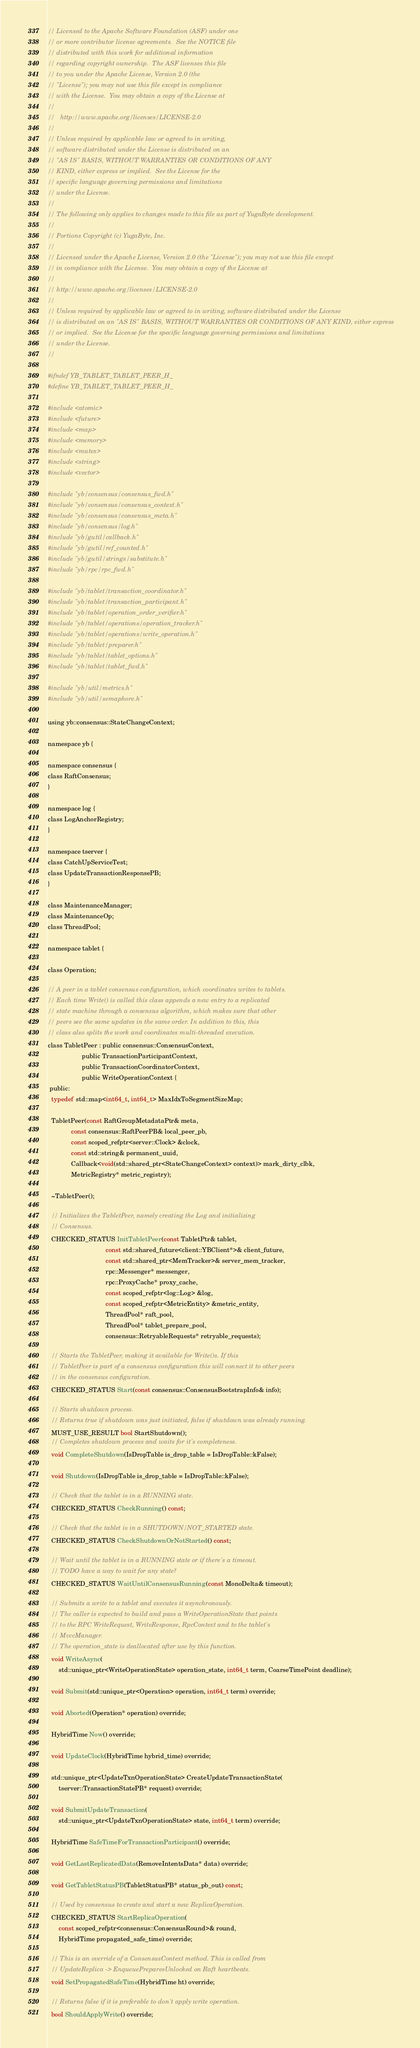<code> <loc_0><loc_0><loc_500><loc_500><_C_>// Licensed to the Apache Software Foundation (ASF) under one
// or more contributor license agreements.  See the NOTICE file
// distributed with this work for additional information
// regarding copyright ownership.  The ASF licenses this file
// to you under the Apache License, Version 2.0 (the
// "License"); you may not use this file except in compliance
// with the License.  You may obtain a copy of the License at
//
//   http://www.apache.org/licenses/LICENSE-2.0
//
// Unless required by applicable law or agreed to in writing,
// software distributed under the License is distributed on an
// "AS IS" BASIS, WITHOUT WARRANTIES OR CONDITIONS OF ANY
// KIND, either express or implied.  See the License for the
// specific language governing permissions and limitations
// under the License.
//
// The following only applies to changes made to this file as part of YugaByte development.
//
// Portions Copyright (c) YugaByte, Inc.
//
// Licensed under the Apache License, Version 2.0 (the "License"); you may not use this file except
// in compliance with the License.  You may obtain a copy of the License at
//
// http://www.apache.org/licenses/LICENSE-2.0
//
// Unless required by applicable law or agreed to in writing, software distributed under the License
// is distributed on an "AS IS" BASIS, WITHOUT WARRANTIES OR CONDITIONS OF ANY KIND, either express
// or implied.  See the License for the specific language governing permissions and limitations
// under the License.
//

#ifndef YB_TABLET_TABLET_PEER_H_
#define YB_TABLET_TABLET_PEER_H_

#include <atomic>
#include <future>
#include <map>
#include <memory>
#include <mutex>
#include <string>
#include <vector>

#include "yb/consensus/consensus_fwd.h"
#include "yb/consensus/consensus_context.h"
#include "yb/consensus/consensus_meta.h"
#include "yb/consensus/log.h"
#include "yb/gutil/callback.h"
#include "yb/gutil/ref_counted.h"
#include "yb/gutil/strings/substitute.h"
#include "yb/rpc/rpc_fwd.h"

#include "yb/tablet/transaction_coordinator.h"
#include "yb/tablet/transaction_participant.h"
#include "yb/tablet/operation_order_verifier.h"
#include "yb/tablet/operations/operation_tracker.h"
#include "yb/tablet/operations/write_operation.h"
#include "yb/tablet/preparer.h"
#include "yb/tablet/tablet_options.h"
#include "yb/tablet/tablet_fwd.h"

#include "yb/util/metrics.h"
#include "yb/util/semaphore.h"

using yb::consensus::StateChangeContext;

namespace yb {

namespace consensus {
class RaftConsensus;
}

namespace log {
class LogAnchorRegistry;
}

namespace tserver {
class CatchUpServiceTest;
class UpdateTransactionResponsePB;
}

class MaintenanceManager;
class MaintenanceOp;
class ThreadPool;

namespace tablet {

class Operation;

// A peer in a tablet consensus configuration, which coordinates writes to tablets.
// Each time Write() is called this class appends a new entry to a replicated
// state machine through a consensus algorithm, which makes sure that other
// peers see the same updates in the same order. In addition to this, this
// class also splits the work and coordinates multi-threaded execution.
class TabletPeer : public consensus::ConsensusContext,
                   public TransactionParticipantContext,
                   public TransactionCoordinatorContext,
                   public WriteOperationContext {
 public:
  typedef std::map<int64_t, int64_t> MaxIdxToSegmentSizeMap;

  TabletPeer(const RaftGroupMetadataPtr& meta,
             const consensus::RaftPeerPB& local_peer_pb,
             const scoped_refptr<server::Clock> &clock,
             const std::string& permanent_uuid,
             Callback<void(std::shared_ptr<StateChangeContext> context)> mark_dirty_clbk,
             MetricRegistry* metric_registry);

  ~TabletPeer();

  // Initializes the TabletPeer, namely creating the Log and initializing
  // Consensus.
  CHECKED_STATUS InitTabletPeer(const TabletPtr& tablet,
                                const std::shared_future<client::YBClient*>& client_future,
                                const std::shared_ptr<MemTracker>& server_mem_tracker,
                                rpc::Messenger* messenger,
                                rpc::ProxyCache* proxy_cache,
                                const scoped_refptr<log::Log> &log,
                                const scoped_refptr<MetricEntity> &metric_entity,
                                ThreadPool* raft_pool,
                                ThreadPool* tablet_prepare_pool,
                                consensus::RetryableRequests* retryable_requests);

  // Starts the TabletPeer, making it available for Write()s. If this
  // TabletPeer is part of a consensus configuration this will connect it to other peers
  // in the consensus configuration.
  CHECKED_STATUS Start(const consensus::ConsensusBootstrapInfo& info);

  // Starts shutdown process.
  // Returns true if shutdown was just initiated, false if shutdown was already running.
  MUST_USE_RESULT bool StartShutdown();
  // Completes shutdown process and waits for it's completeness.
  void CompleteShutdown(IsDropTable is_drop_table = IsDropTable::kFalse);

  void Shutdown(IsDropTable is_drop_table = IsDropTable::kFalse);

  // Check that the tablet is in a RUNNING state.
  CHECKED_STATUS CheckRunning() const;

  // Check that the tablet is in a SHUTDOWN/NOT_STARTED state.
  CHECKED_STATUS CheckShutdownOrNotStarted() const;

  // Wait until the tablet is in a RUNNING state or if there's a timeout.
  // TODO have a way to wait for any state?
  CHECKED_STATUS WaitUntilConsensusRunning(const MonoDelta& timeout);

  // Submits a write to a tablet and executes it asynchronously.
  // The caller is expected to build and pass a WriteOperationState that points
  // to the RPC WriteRequest, WriteResponse, RpcContext and to the tablet's
  // MvccManager.
  // The operation_state is deallocated after use by this function.
  void WriteAsync(
      std::unique_ptr<WriteOperationState> operation_state, int64_t term, CoarseTimePoint deadline);

  void Submit(std::unique_ptr<Operation> operation, int64_t term) override;

  void Aborted(Operation* operation) override;

  HybridTime Now() override;

  void UpdateClock(HybridTime hybrid_time) override;

  std::unique_ptr<UpdateTxnOperationState> CreateUpdateTransactionState(
      tserver::TransactionStatePB* request) override;

  void SubmitUpdateTransaction(
      std::unique_ptr<UpdateTxnOperationState> state, int64_t term) override;

  HybridTime SafeTimeForTransactionParticipant() override;

  void GetLastReplicatedData(RemoveIntentsData* data) override;

  void GetTabletStatusPB(TabletStatusPB* status_pb_out) const;

  // Used by consensus to create and start a new ReplicaOperation.
  CHECKED_STATUS StartReplicaOperation(
      const scoped_refptr<consensus::ConsensusRound>& round,
      HybridTime propagated_safe_time) override;

  // This is an override of a ConsensusContext method. This is called from
  // UpdateReplica -> EnqueuePreparesUnlocked on Raft heartbeats.
  void SetPropagatedSafeTime(HybridTime ht) override;

  // Returns false if it is preferable to don't apply write operation.
  bool ShouldApplyWrite() override;
</code> 